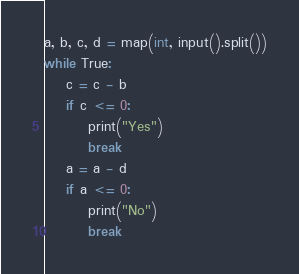Convert code to text. <code><loc_0><loc_0><loc_500><loc_500><_C_>a, b, c, d = map(int, input().split())
while True:
    c = c - b
    if c <= 0:
        print("Yes")
        break
    a = a - d
    if a <= 0:
        print("No")
        break
</code> 